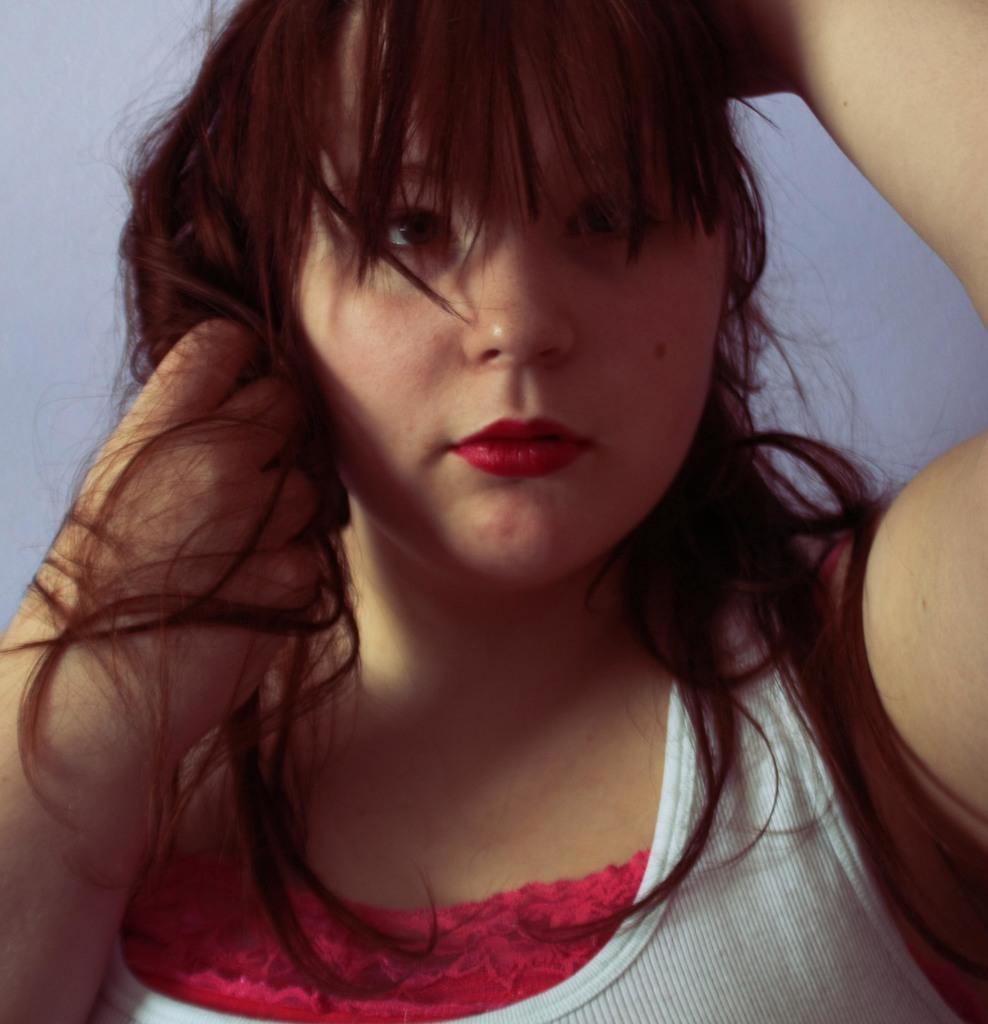Who is the main subject in the foreground of the image? There is a woman in the foreground of the image. What type of thrill can be seen on the woman's face in the image? There is no indication of a thrill or any specific emotion on the woman's face in the image. 